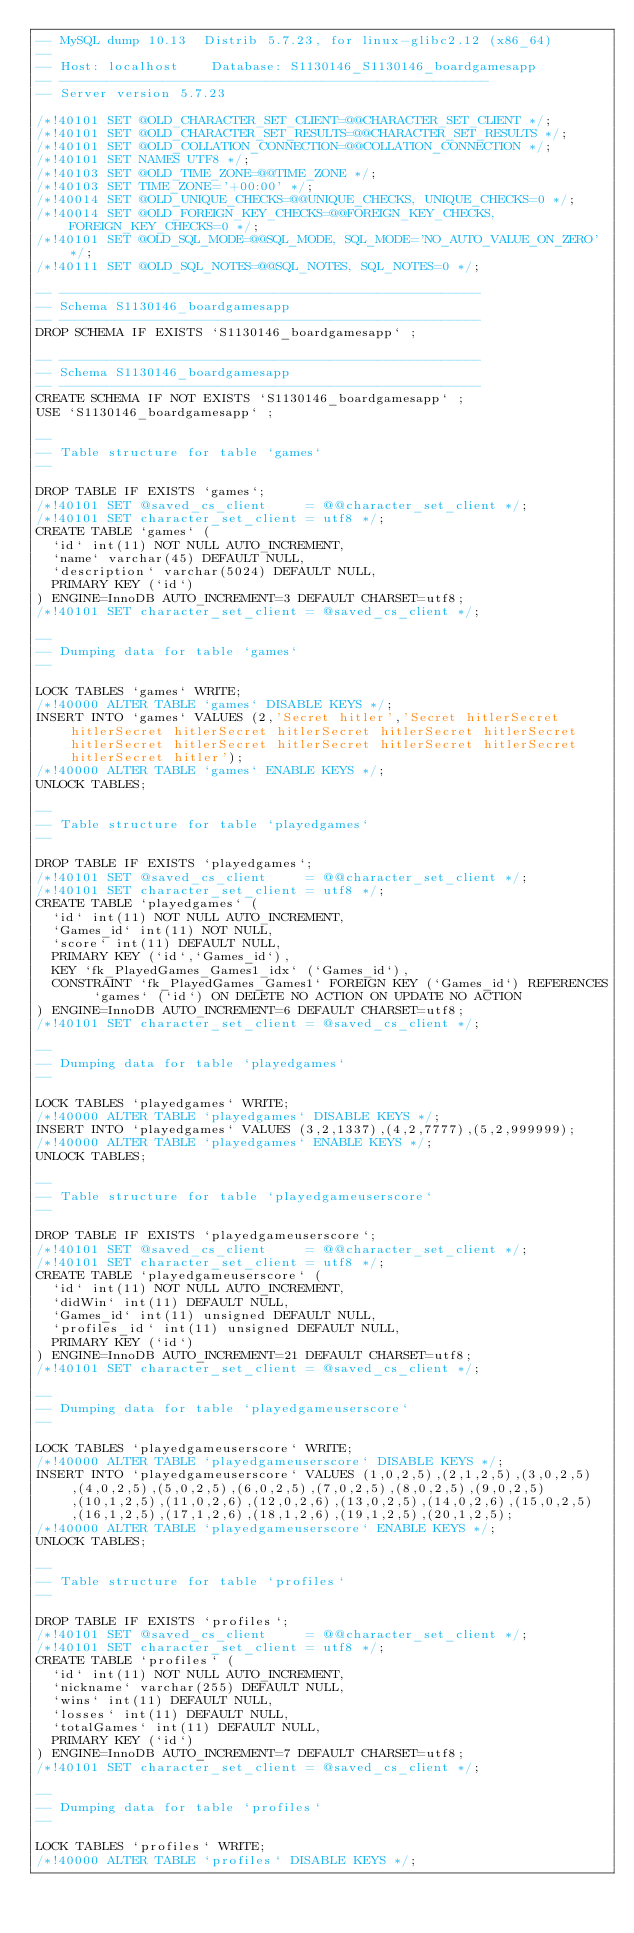Convert code to text. <code><loc_0><loc_0><loc_500><loc_500><_SQL_>-- MySQL dump 10.13  Distrib 5.7.23, for linux-glibc2.12 (x86_64)
--
-- Host: localhost    Database: S1130146_S1130146_boardgamesapp
-- ------------------------------------------------------
-- Server version	5.7.23

/*!40101 SET @OLD_CHARACTER_SET_CLIENT=@@CHARACTER_SET_CLIENT */;
/*!40101 SET @OLD_CHARACTER_SET_RESULTS=@@CHARACTER_SET_RESULTS */;
/*!40101 SET @OLD_COLLATION_CONNECTION=@@COLLATION_CONNECTION */;
/*!40101 SET NAMES UTF8 */;
/*!40103 SET @OLD_TIME_ZONE=@@TIME_ZONE */;
/*!40103 SET TIME_ZONE='+00:00' */;
/*!40014 SET @OLD_UNIQUE_CHECKS=@@UNIQUE_CHECKS, UNIQUE_CHECKS=0 */;
/*!40014 SET @OLD_FOREIGN_KEY_CHECKS=@@FOREIGN_KEY_CHECKS, FOREIGN_KEY_CHECKS=0 */;
/*!40101 SET @OLD_SQL_MODE=@@SQL_MODE, SQL_MODE='NO_AUTO_VALUE_ON_ZERO' */;
/*!40111 SET @OLD_SQL_NOTES=@@SQL_NOTES, SQL_NOTES=0 */;

-- -----------------------------------------------------
-- Schema S1130146_boardgamesapp
-- -----------------------------------------------------
DROP SCHEMA IF EXISTS `S1130146_boardgamesapp` ;

-- -----------------------------------------------------
-- Schema S1130146_boardgamesapp
-- -----------------------------------------------------
CREATE SCHEMA IF NOT EXISTS `S1130146_boardgamesapp` ;
USE `S1130146_boardgamesapp` ;

--
-- Table structure for table `games`
--

DROP TABLE IF EXISTS `games`;
/*!40101 SET @saved_cs_client     = @@character_set_client */;
/*!40101 SET character_set_client = utf8 */;
CREATE TABLE `games` (
  `id` int(11) NOT NULL AUTO_INCREMENT,
  `name` varchar(45) DEFAULT NULL,
  `description` varchar(5024) DEFAULT NULL,
  PRIMARY KEY (`id`)
) ENGINE=InnoDB AUTO_INCREMENT=3 DEFAULT CHARSET=utf8;
/*!40101 SET character_set_client = @saved_cs_client */;

--
-- Dumping data for table `games`
--

LOCK TABLES `games` WRITE;
/*!40000 ALTER TABLE `games` DISABLE KEYS */;
INSERT INTO `games` VALUES (2,'Secret hitler','Secret hitlerSecret hitlerSecret hitlerSecret hitlerSecret hitlerSecret hitlerSecret hitlerSecret hitlerSecret hitlerSecret hitlerSecret hitlerSecret hitlerSecret hitler');
/*!40000 ALTER TABLE `games` ENABLE KEYS */;
UNLOCK TABLES;

--
-- Table structure for table `playedgames`
--

DROP TABLE IF EXISTS `playedgames`;
/*!40101 SET @saved_cs_client     = @@character_set_client */;
/*!40101 SET character_set_client = utf8 */;
CREATE TABLE `playedgames` (
  `id` int(11) NOT NULL AUTO_INCREMENT,
  `Games_id` int(11) NOT NULL,
  `score` int(11) DEFAULT NULL,
  PRIMARY KEY (`id`,`Games_id`),
  KEY `fk_PlayedGames_Games1_idx` (`Games_id`),
  CONSTRAINT `fk_PlayedGames_Games1` FOREIGN KEY (`Games_id`) REFERENCES `games` (`id`) ON DELETE NO ACTION ON UPDATE NO ACTION
) ENGINE=InnoDB AUTO_INCREMENT=6 DEFAULT CHARSET=utf8;
/*!40101 SET character_set_client = @saved_cs_client */;

--
-- Dumping data for table `playedgames`
--

LOCK TABLES `playedgames` WRITE;
/*!40000 ALTER TABLE `playedgames` DISABLE KEYS */;
INSERT INTO `playedgames` VALUES (3,2,1337),(4,2,7777),(5,2,999999);
/*!40000 ALTER TABLE `playedgames` ENABLE KEYS */;
UNLOCK TABLES;

--
-- Table structure for table `playedgameuserscore`
--

DROP TABLE IF EXISTS `playedgameuserscore`;
/*!40101 SET @saved_cs_client     = @@character_set_client */;
/*!40101 SET character_set_client = utf8 */;
CREATE TABLE `playedgameuserscore` (
  `id` int(11) NOT NULL AUTO_INCREMENT,
  `didWin` int(11) DEFAULT NULL,
  `Games_id` int(11) unsigned DEFAULT NULL,
  `profiles_id` int(11) unsigned DEFAULT NULL,
  PRIMARY KEY (`id`)
) ENGINE=InnoDB AUTO_INCREMENT=21 DEFAULT CHARSET=utf8;
/*!40101 SET character_set_client = @saved_cs_client */;

--
-- Dumping data for table `playedgameuserscore`
--

LOCK TABLES `playedgameuserscore` WRITE;
/*!40000 ALTER TABLE `playedgameuserscore` DISABLE KEYS */;
INSERT INTO `playedgameuserscore` VALUES (1,0,2,5),(2,1,2,5),(3,0,2,5),(4,0,2,5),(5,0,2,5),(6,0,2,5),(7,0,2,5),(8,0,2,5),(9,0,2,5),(10,1,2,5),(11,0,2,6),(12,0,2,6),(13,0,2,5),(14,0,2,6),(15,0,2,5),(16,1,2,5),(17,1,2,6),(18,1,2,6),(19,1,2,5),(20,1,2,5);
/*!40000 ALTER TABLE `playedgameuserscore` ENABLE KEYS */;
UNLOCK TABLES;

--
-- Table structure for table `profiles`
--

DROP TABLE IF EXISTS `profiles`;
/*!40101 SET @saved_cs_client     = @@character_set_client */;
/*!40101 SET character_set_client = utf8 */;
CREATE TABLE `profiles` (
  `id` int(11) NOT NULL AUTO_INCREMENT,
  `nickname` varchar(255) DEFAULT NULL,
  `wins` int(11) DEFAULT NULL,
  `losses` int(11) DEFAULT NULL,
  `totalGames` int(11) DEFAULT NULL,
  PRIMARY KEY (`id`)
) ENGINE=InnoDB AUTO_INCREMENT=7 DEFAULT CHARSET=utf8;
/*!40101 SET character_set_client = @saved_cs_client */;

--
-- Dumping data for table `profiles`
--

LOCK TABLES `profiles` WRITE;
/*!40000 ALTER TABLE `profiles` DISABLE KEYS */;</code> 